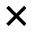Convert formula to latex. <formula><loc_0><loc_0><loc_500><loc_500>\times</formula> 